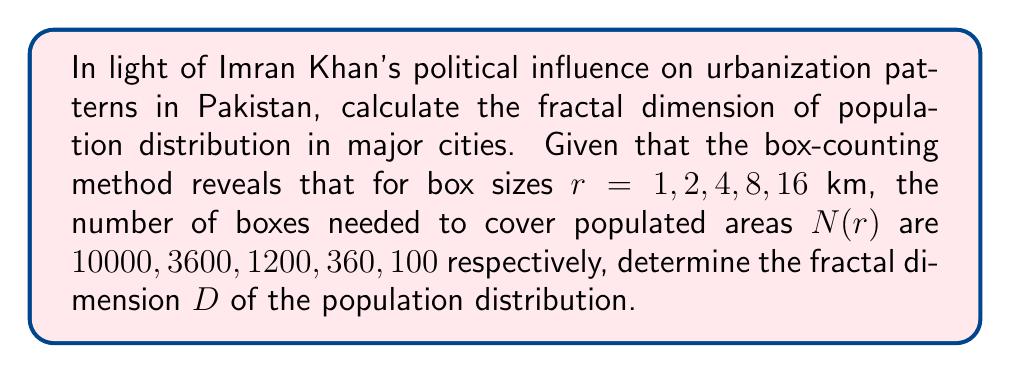Can you answer this question? To calculate the fractal dimension using the box-counting method, we follow these steps:

1) The fractal dimension $D$ is given by the formula:

   $$D = -\lim_{r \to 0} \frac{\log N(r)}{\log r}$$

2) In practice, we estimate this by plotting $\log N(r)$ against $\log r$ and finding the slope of the best-fit line.

3) Let's create a table of $\log r$ and $\log N(r)$:

   | $r$ | $N(r)$ | $\log r$ | $\log N(r)$ |
   |-----|--------|----------|-------------|
   | 1   | 10000  | 0        | 4           |
   | 2   | 3600   | 0.301    | 3.556       |
   | 4   | 1200   | 0.602    | 3.079       |
   | 8   | 360    | 0.903    | 2.556       |
   | 16  | 100    | 1.204    | 2           |

4) We can use the least squares method to find the slope of the best-fit line. The formula for the slope is:

   $$m = \frac{n\sum(xy) - \sum x \sum y}{n\sum x^2 - (\sum x)^2}$$

   where $x = \log r$ and $y = \log N(r)$

5) Calculating the sums:
   $\sum x = 3.01$
   $\sum y = 15.191$
   $\sum xy = 7.249$
   $\sum x^2 = 2.416$
   $n = 5$

6) Plugging into the slope formula:

   $$m = \frac{5(7.249) - (3.01)(15.191)}{5(2.416) - (3.01)^2} = -1.658$$

7) The fractal dimension $D$ is the negative of this slope:

   $$D = -(-1.658) = 1.658$$

This fractal dimension suggests that the population distribution in Pakistan's major cities, influenced by Imran Khan's policies, exhibits a pattern between a line (dimension 1) and a filled plane (dimension 2), indicating a complex, space-filling urban sprawl.
Answer: The fractal dimension of the population distribution is approximately $1.658$. 